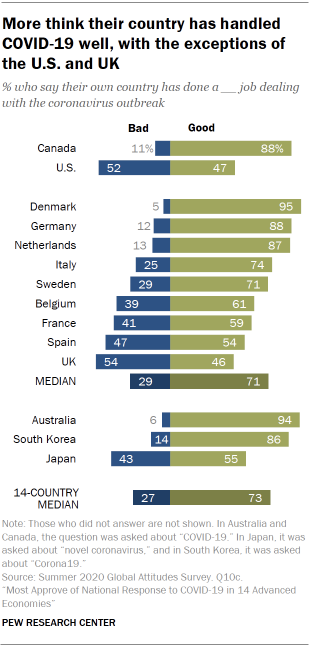Give some essential details in this illustration. According to a recent survey, 47% of Americans believe that their government is doing a good job. It is generally believed that in 14 countries, the government is widely admired and appreciated by the people for its positive actions and policies. 